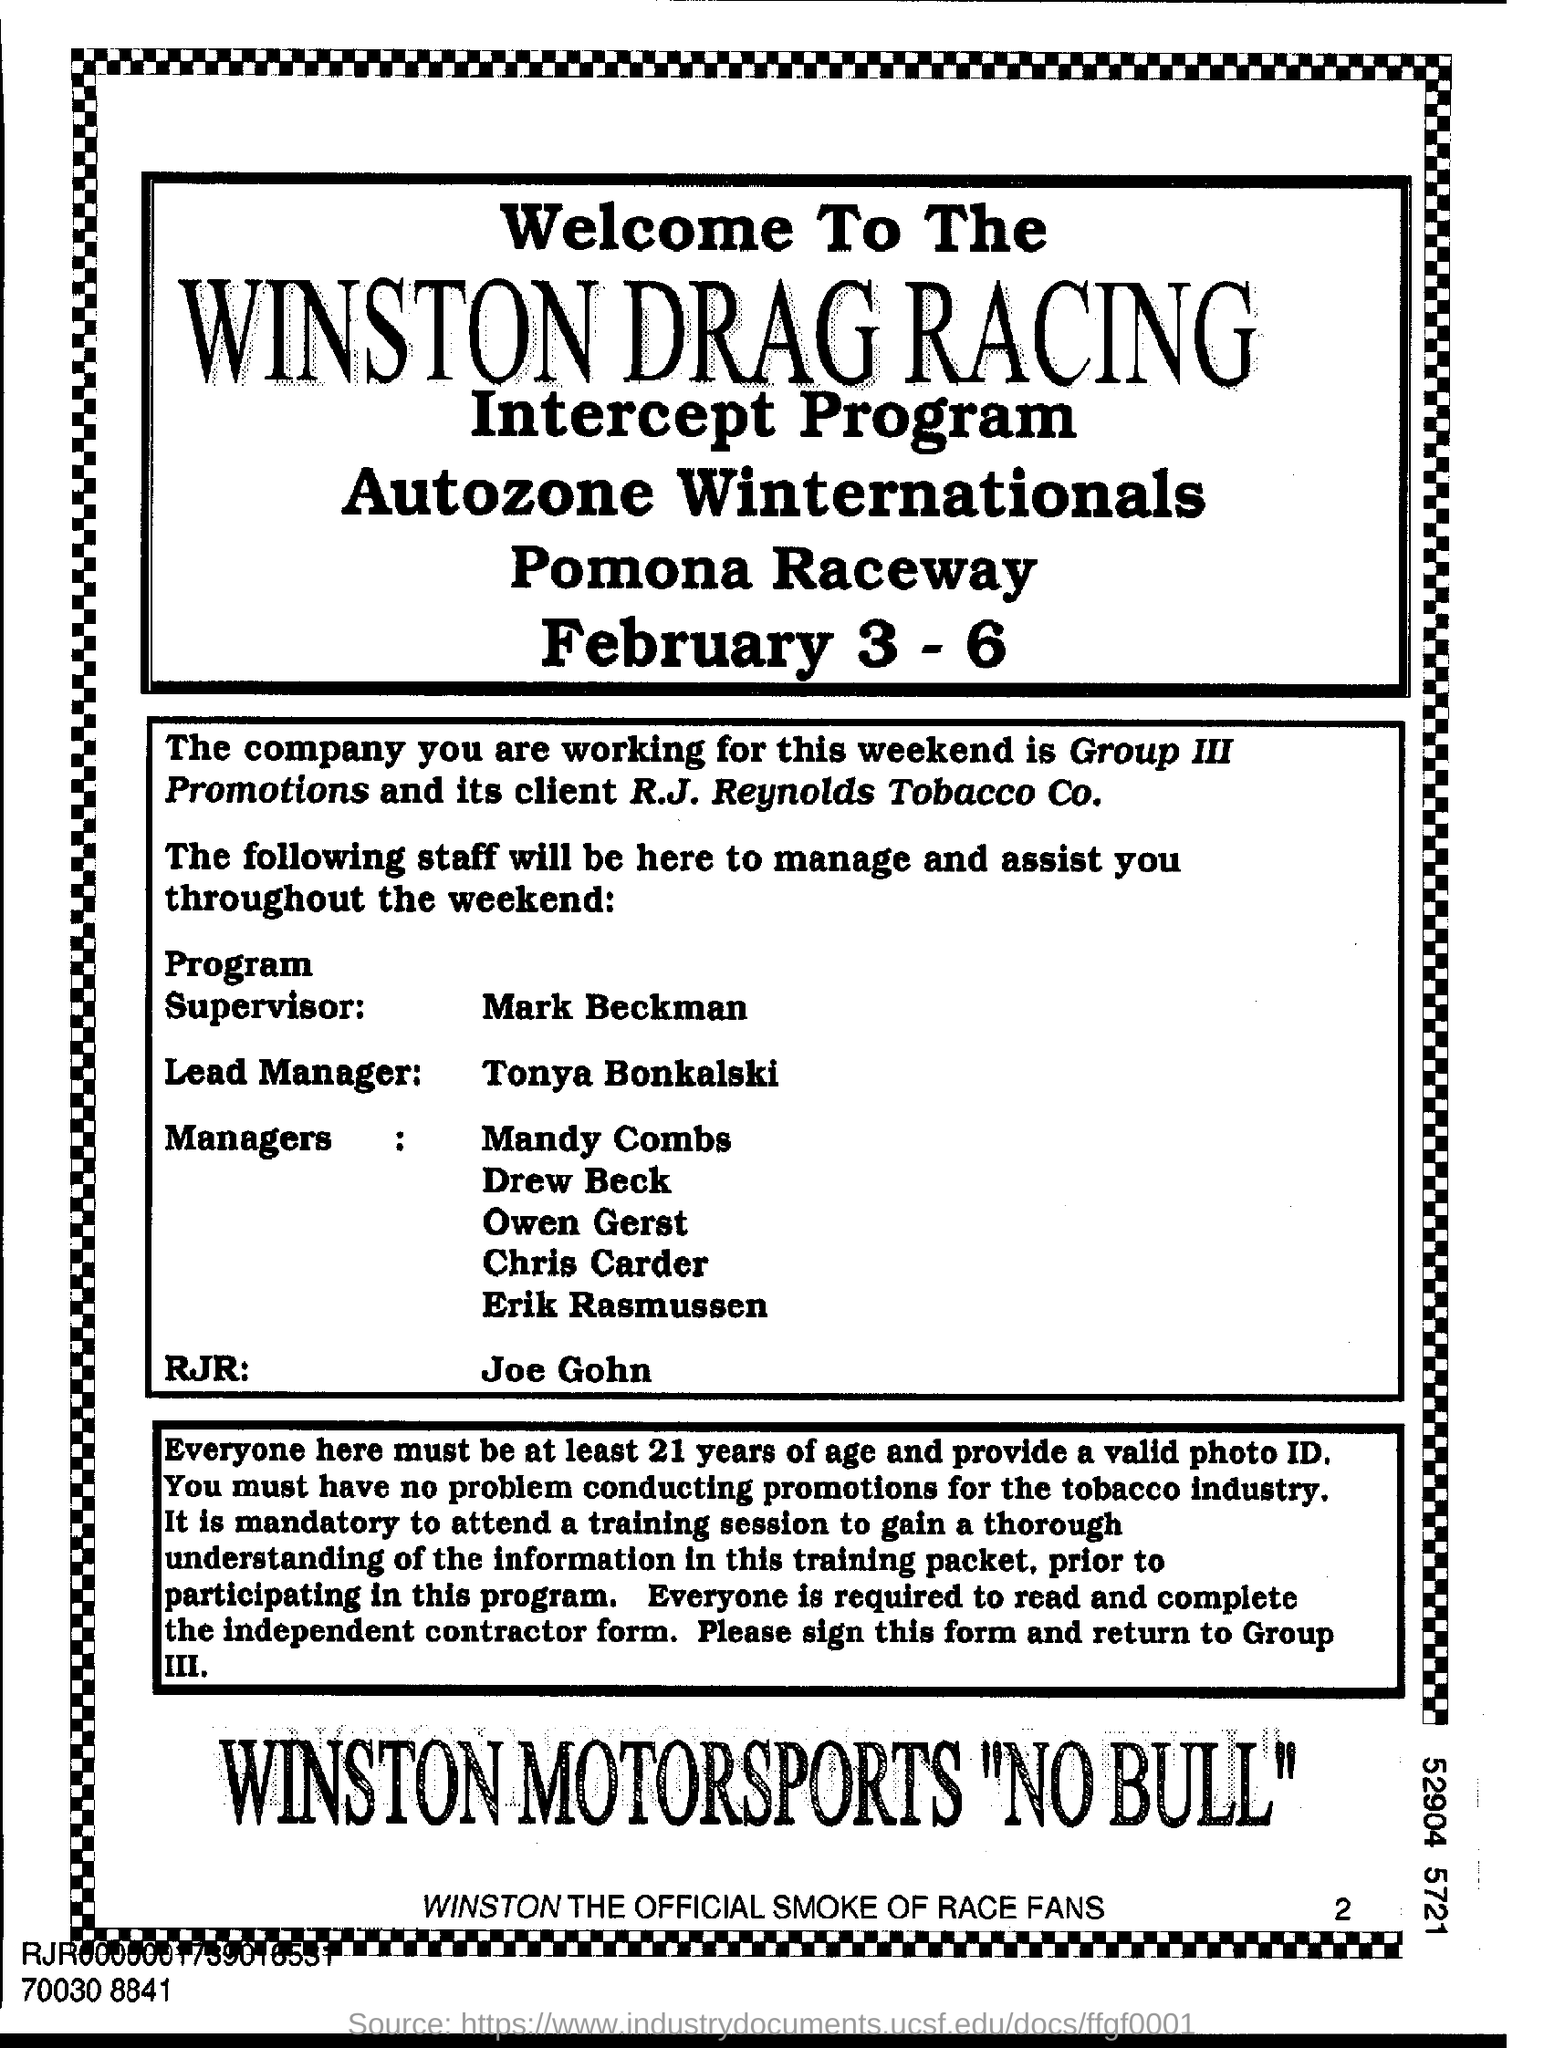List a handful of essential elements in this visual. The Intercept program is scheduled to take place from February 3 to 6. The flyer is about the Winston Drag Racing Intercept Program, which aims to provide information about drag racing and its dangers to children. Group III Promotions is the client of R.J. Reynolds Tobacco Co. The program supervisor for the intercept program is Mark Beckman. The program supervisor is Mark Beckman. 